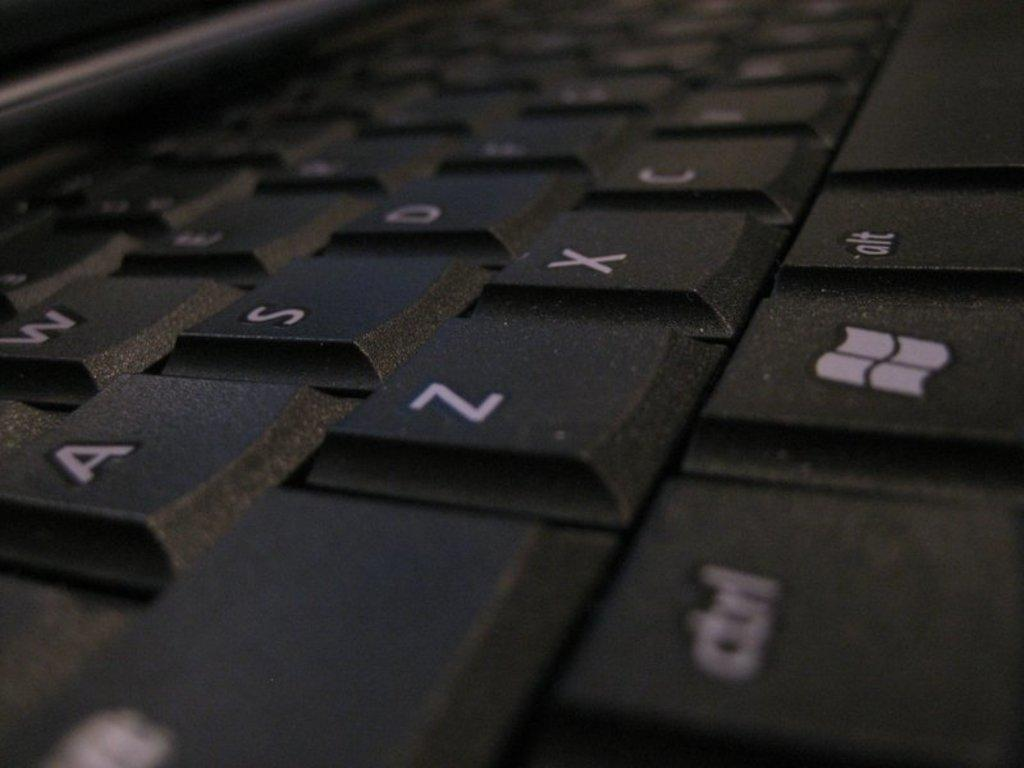<image>
Render a clear and concise summary of the photo. Black keyboard with the alt key next to a windows key and spacebar. 